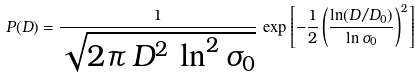Convert formula to latex. <formula><loc_0><loc_0><loc_500><loc_500>P ( D ) = \frac { 1 } { \sqrt { 2 \pi \, D ^ { 2 } \, \ln ^ { 2 } \sigma _ { 0 } } } \, \exp \left [ - \frac { 1 } { 2 } \left ( \frac { \ln ( D / D _ { 0 } ) } { \ln \sigma _ { 0 } } \right ) ^ { 2 } \right ]</formula> 